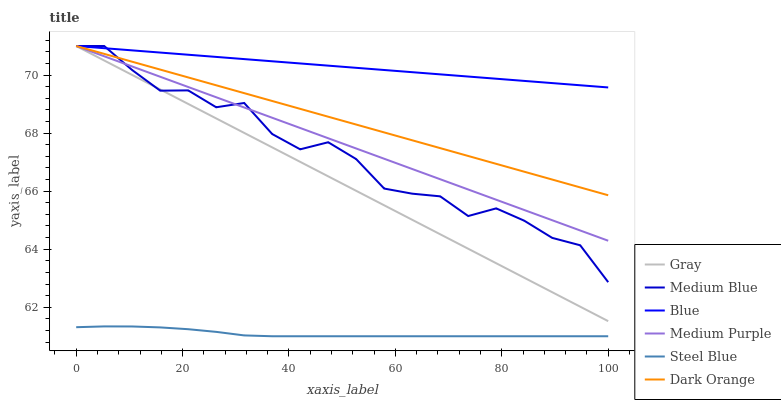Does Steel Blue have the minimum area under the curve?
Answer yes or no. Yes. Does Blue have the maximum area under the curve?
Answer yes or no. Yes. Does Gray have the minimum area under the curve?
Answer yes or no. No. Does Gray have the maximum area under the curve?
Answer yes or no. No. Is Medium Purple the smoothest?
Answer yes or no. Yes. Is Medium Blue the roughest?
Answer yes or no. Yes. Is Gray the smoothest?
Answer yes or no. No. Is Gray the roughest?
Answer yes or no. No. Does Steel Blue have the lowest value?
Answer yes or no. Yes. Does Gray have the lowest value?
Answer yes or no. No. Does Medium Purple have the highest value?
Answer yes or no. Yes. Does Steel Blue have the highest value?
Answer yes or no. No. Is Steel Blue less than Dark Orange?
Answer yes or no. Yes. Is Gray greater than Steel Blue?
Answer yes or no. Yes. Does Gray intersect Medium Blue?
Answer yes or no. Yes. Is Gray less than Medium Blue?
Answer yes or no. No. Is Gray greater than Medium Blue?
Answer yes or no. No. Does Steel Blue intersect Dark Orange?
Answer yes or no. No. 